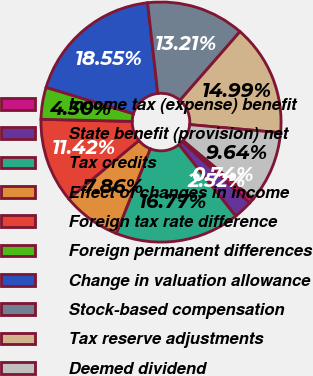Convert chart to OTSL. <chart><loc_0><loc_0><loc_500><loc_500><pie_chart><fcel>Income tax (expense) benefit<fcel>State benefit (provision) net<fcel>Tax credits<fcel>Effect of changes in income<fcel>Foreign tax rate difference<fcel>Foreign permanent differences<fcel>Change in valuation allowance<fcel>Stock-based compensation<fcel>Tax reserve adjustments<fcel>Deemed dividend<nl><fcel>0.74%<fcel>2.52%<fcel>16.77%<fcel>7.86%<fcel>11.42%<fcel>4.3%<fcel>18.55%<fcel>13.21%<fcel>14.99%<fcel>9.64%<nl></chart> 